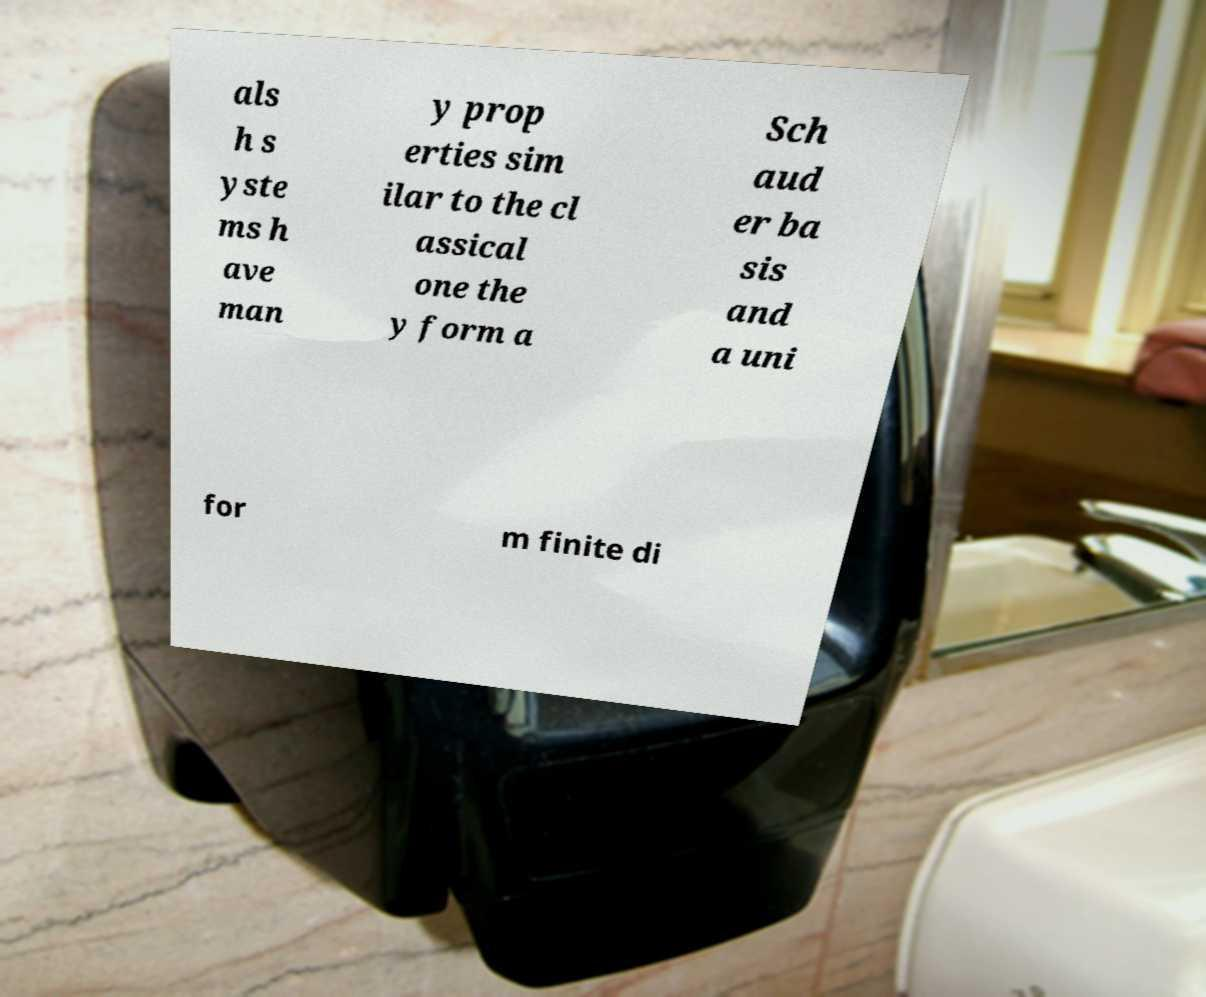Please read and relay the text visible in this image. What does it say? als h s yste ms h ave man y prop erties sim ilar to the cl assical one the y form a Sch aud er ba sis and a uni for m finite di 